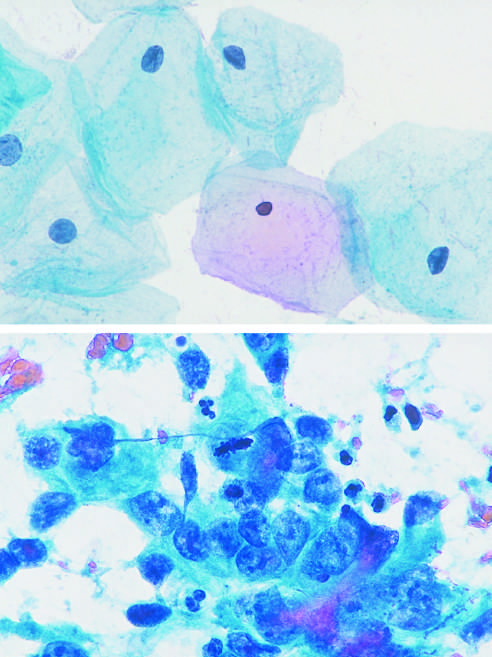re large, flat cells with small nuclei typical?
Answer the question using a single word or phrase. Yes 